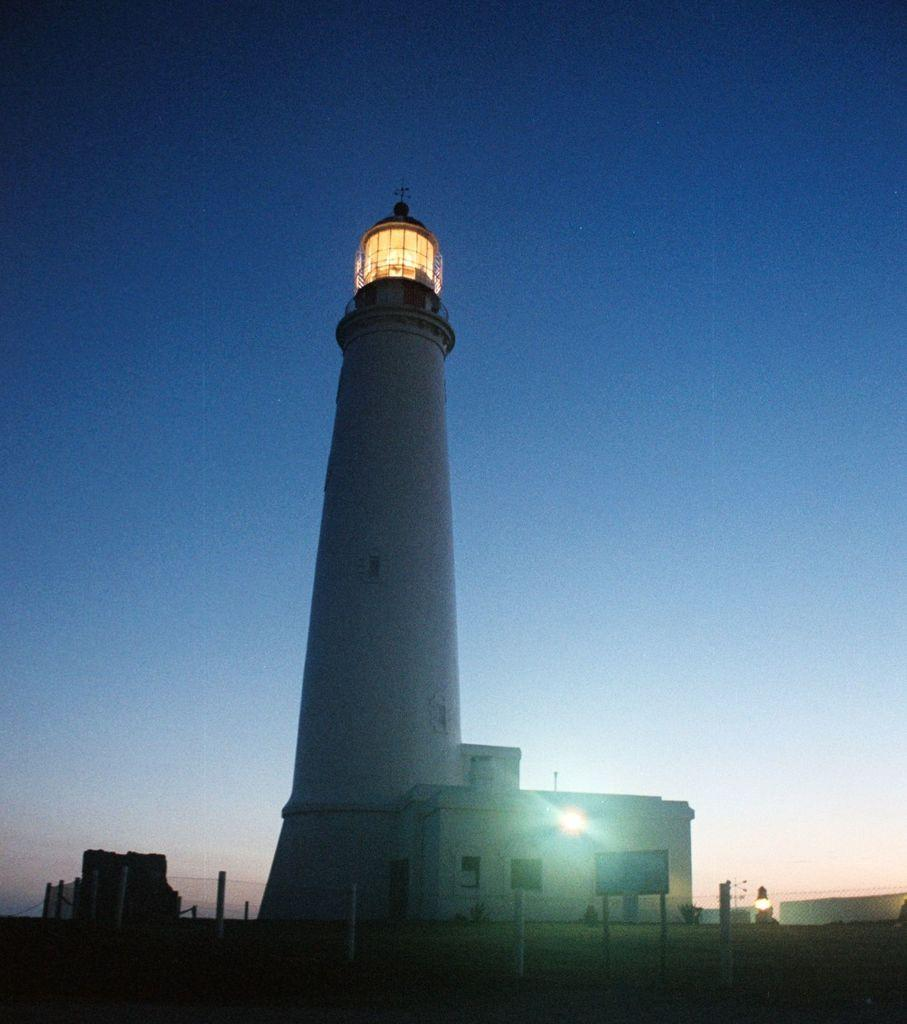What is located in the center of the image? There are buildings, boards, and lights in the center of the image. Can you describe the lights in the image? The lights are visible in the center of the image. What can be seen in the background of the image? The sky is visible in the background of the image. What type of insurance policy is being discussed by the committee in the image? There is no committee or discussion of insurance policies present in the image. Can you see any balloons in the image? There are no balloons present in the image. 